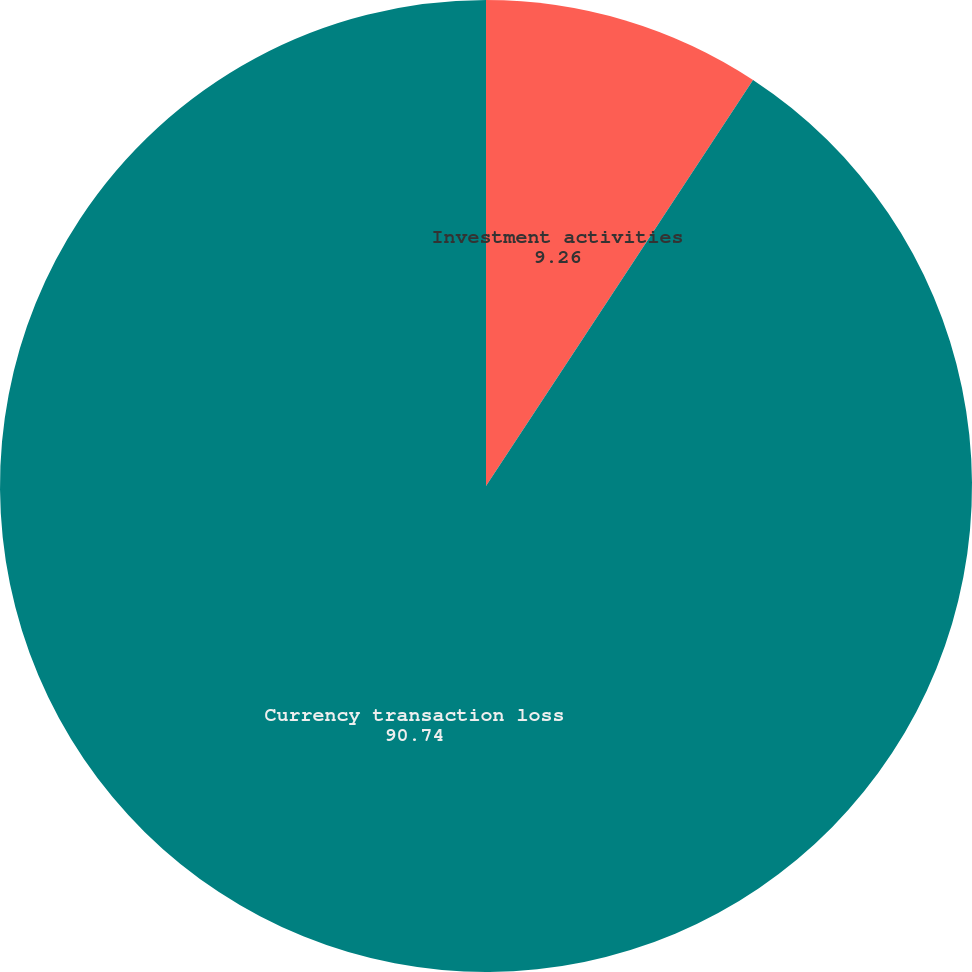Convert chart to OTSL. <chart><loc_0><loc_0><loc_500><loc_500><pie_chart><fcel>Investment activities<fcel>Currency transaction loss<nl><fcel>9.26%<fcel>90.74%<nl></chart> 